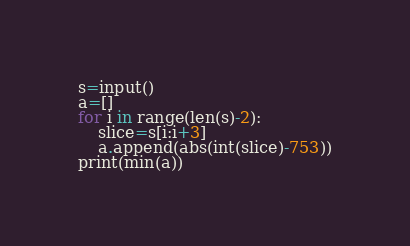<code> <loc_0><loc_0><loc_500><loc_500><_Python_>s=input()
a=[]
for i in range(len(s)-2):
    slice=s[i:i+3]
    a.append(abs(int(slice)-753))
print(min(a))   </code> 